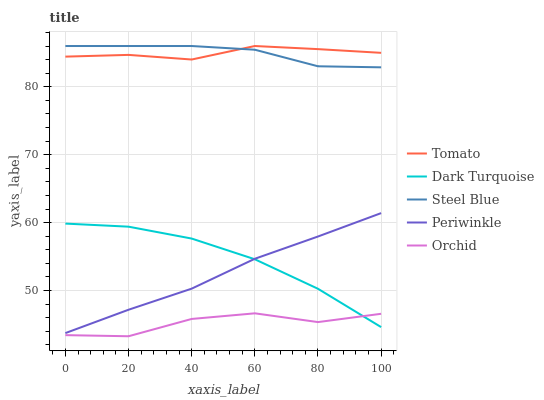Does Orchid have the minimum area under the curve?
Answer yes or no. Yes. Does Tomato have the maximum area under the curve?
Answer yes or no. Yes. Does Dark Turquoise have the minimum area under the curve?
Answer yes or no. No. Does Dark Turquoise have the maximum area under the curve?
Answer yes or no. No. Is Periwinkle the smoothest?
Answer yes or no. Yes. Is Orchid the roughest?
Answer yes or no. Yes. Is Dark Turquoise the smoothest?
Answer yes or no. No. Is Dark Turquoise the roughest?
Answer yes or no. No. Does Orchid have the lowest value?
Answer yes or no. Yes. Does Dark Turquoise have the lowest value?
Answer yes or no. No. Does Steel Blue have the highest value?
Answer yes or no. Yes. Does Dark Turquoise have the highest value?
Answer yes or no. No. Is Periwinkle less than Tomato?
Answer yes or no. Yes. Is Steel Blue greater than Periwinkle?
Answer yes or no. Yes. Does Periwinkle intersect Dark Turquoise?
Answer yes or no. Yes. Is Periwinkle less than Dark Turquoise?
Answer yes or no. No. Is Periwinkle greater than Dark Turquoise?
Answer yes or no. No. Does Periwinkle intersect Tomato?
Answer yes or no. No. 